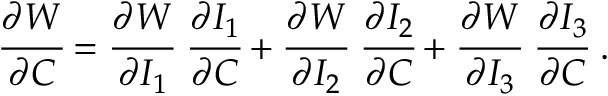Convert formula to latex. <formula><loc_0><loc_0><loc_500><loc_500>{ \cfrac { \partial W } { \partial { C } } } = { \cfrac { \partial W } { \partial I _ { 1 } } } { \cfrac { \partial I _ { 1 } } { \partial { C } } } + { \cfrac { \partial W } { \partial I _ { 2 } } } { \cfrac { \partial I _ { 2 } } { \partial { C } } } + { \cfrac { \partial W } { \partial I _ { 3 } } } { \cfrac { \partial I _ { 3 } } { \partial { C } } } .</formula> 